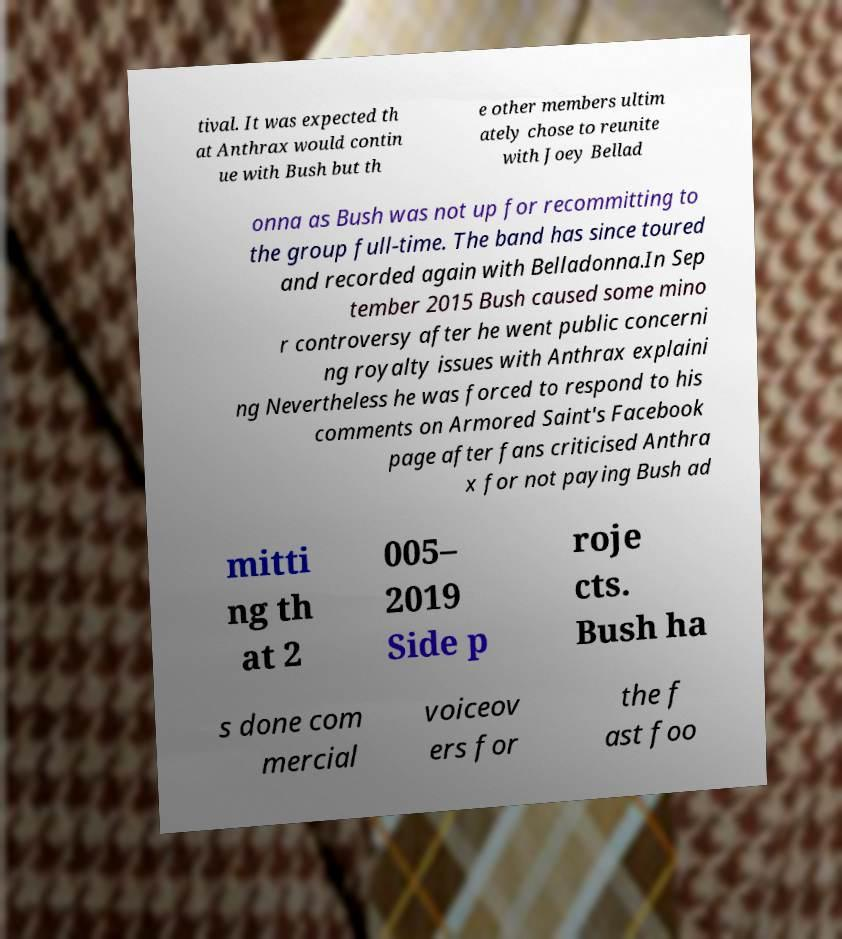There's text embedded in this image that I need extracted. Can you transcribe it verbatim? tival. It was expected th at Anthrax would contin ue with Bush but th e other members ultim ately chose to reunite with Joey Bellad onna as Bush was not up for recommitting to the group full-time. The band has since toured and recorded again with Belladonna.In Sep tember 2015 Bush caused some mino r controversy after he went public concerni ng royalty issues with Anthrax explaini ng Nevertheless he was forced to respond to his comments on Armored Saint's Facebook page after fans criticised Anthra x for not paying Bush ad mitti ng th at 2 005– 2019 Side p roje cts. Bush ha s done com mercial voiceov ers for the f ast foo 